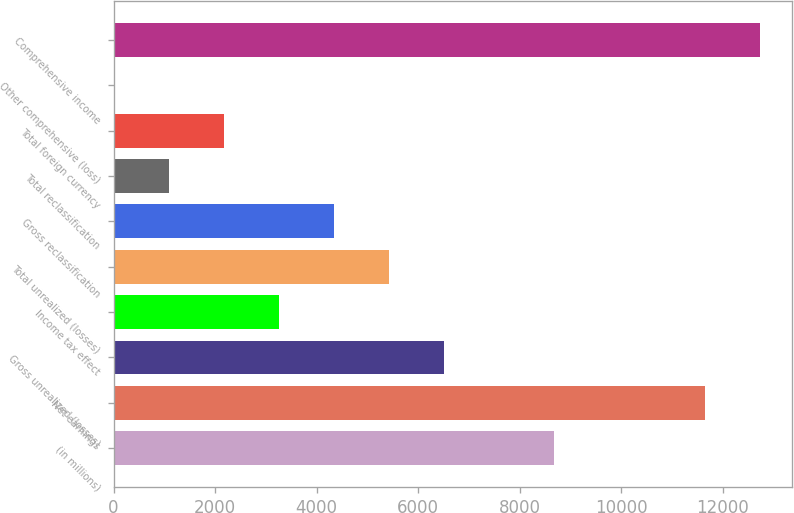<chart> <loc_0><loc_0><loc_500><loc_500><bar_chart><fcel>(in millions)<fcel>Net earnings<fcel>Gross unrealized (losses)<fcel>Income tax effect<fcel>Total unrealized (losses)<fcel>Gross reclassification<fcel>Total reclassification<fcel>Total foreign currency<fcel>Other comprehensive (loss)<fcel>Comprehensive income<nl><fcel>8672.4<fcel>11654.3<fcel>6507.8<fcel>3260.9<fcel>5425.5<fcel>4343.2<fcel>1096.3<fcel>2178.6<fcel>14<fcel>12736.6<nl></chart> 